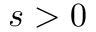Convert formula to latex. <formula><loc_0><loc_0><loc_500><loc_500>s > 0</formula> 